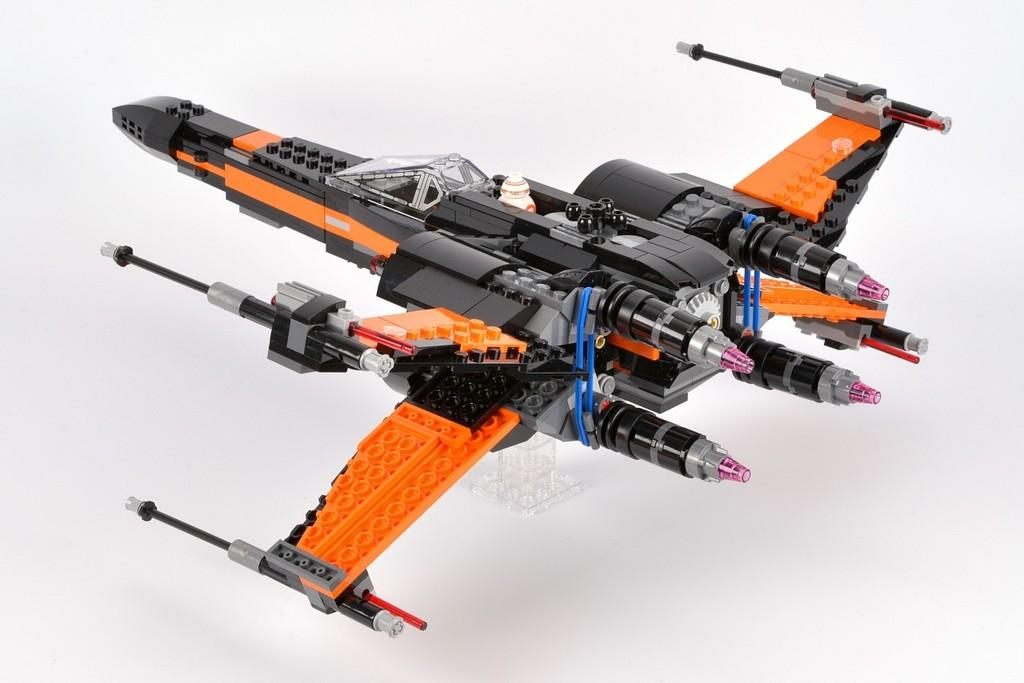What is the main subject of the image? The main subject of the image is an airplane-shaped object. How many clams can be seen in the image? There are no clams present in the image. What scientific principle is demonstrated in the image? The image does not depict any scientific principle; it features an airplane-shaped object. 